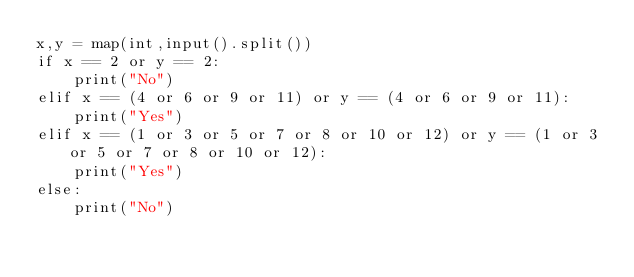<code> <loc_0><loc_0><loc_500><loc_500><_Python_>x,y = map(int,input().split())
if x == 2 or y == 2:
    print("No")
elif x == (4 or 6 or 9 or 11) or y == (4 or 6 or 9 or 11):
    print("Yes")
elif x == (1 or 3 or 5 or 7 or 8 or 10 or 12) or y == (1 or 3 or 5 or 7 or 8 or 10 or 12):
    print("Yes")
else:
    print("No")</code> 